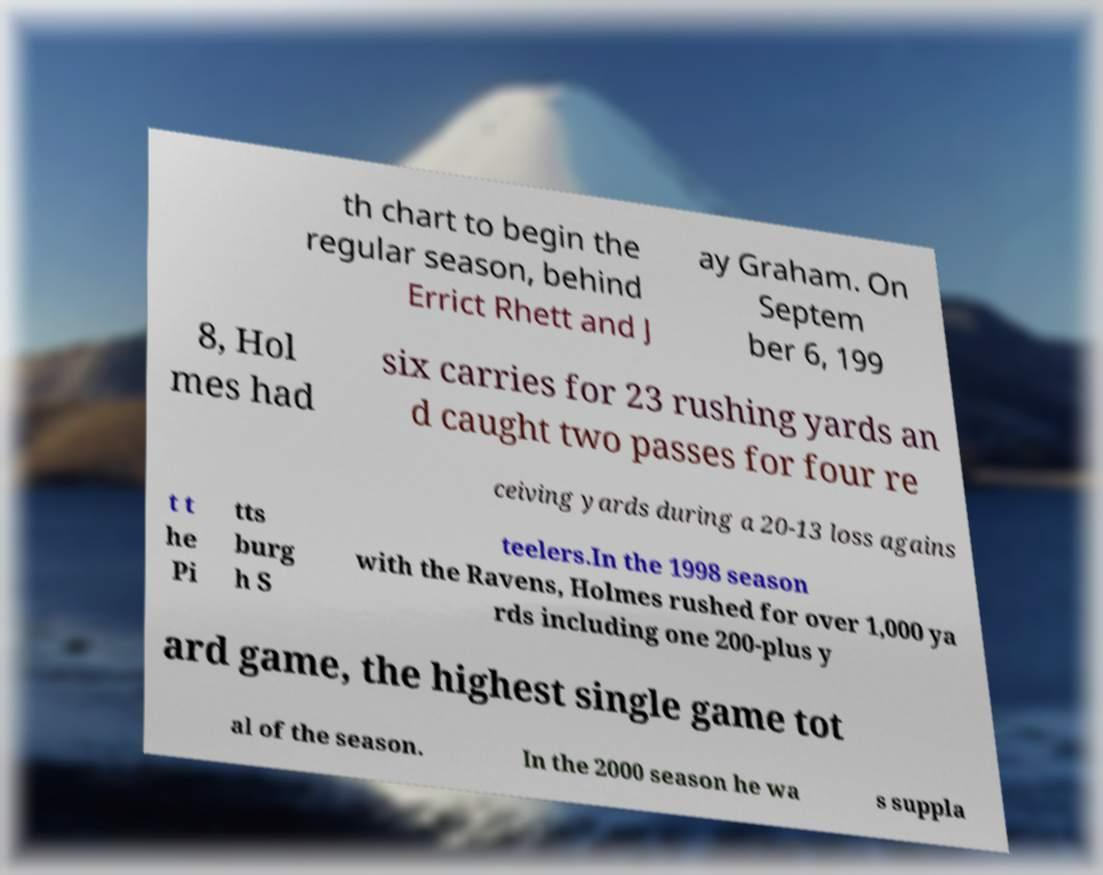Could you assist in decoding the text presented in this image and type it out clearly? th chart to begin the regular season, behind Errict Rhett and J ay Graham. On Septem ber 6, 199 8, Hol mes had six carries for 23 rushing yards an d caught two passes for four re ceiving yards during a 20-13 loss agains t t he Pi tts burg h S teelers.In the 1998 season with the Ravens, Holmes rushed for over 1,000 ya rds including one 200-plus y ard game, the highest single game tot al of the season. In the 2000 season he wa s suppla 